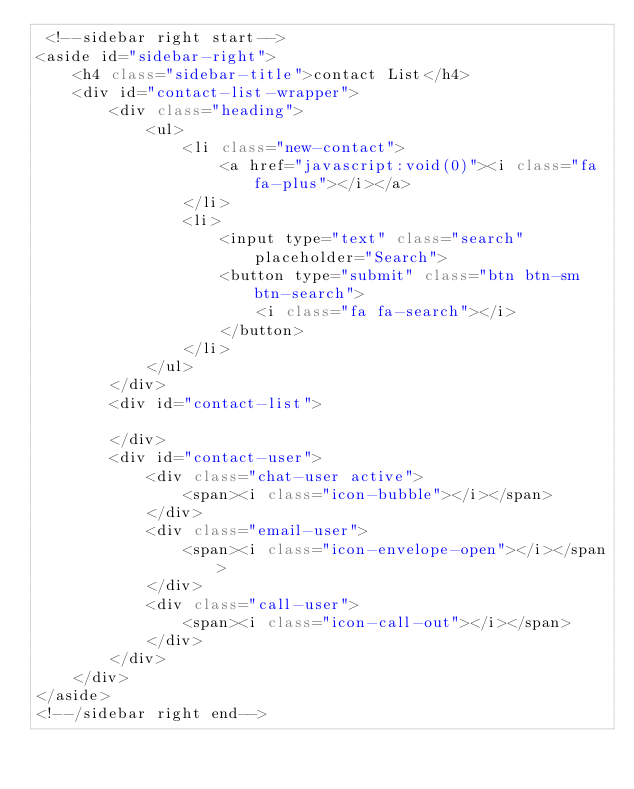<code> <loc_0><loc_0><loc_500><loc_500><_C#_> <!--sidebar right start-->
<aside id="sidebar-right">
    <h4 class="sidebar-title">contact List</h4>
    <div id="contact-list-wrapper">
        <div class="heading">
            <ul>
                <li class="new-contact">
                    <a href="javascript:void(0)"><i class="fa fa-plus"></i></a>
                </li>
                <li>
                    <input type="text" class="search" placeholder="Search">
                    <button type="submit" class="btn btn-sm btn-search">
                        <i class="fa fa-search"></i>
                    </button>
                </li>
            </ul>
        </div>
        <div id="contact-list">

        </div>
        <div id="contact-user">
            <div class="chat-user active">
                <span><i class="icon-bubble"></i></span>
            </div>
            <div class="email-user">
                <span><i class="icon-envelope-open"></i></span>
            </div>
            <div class="call-user">
                <span><i class="icon-call-out"></i></span>
            </div>
        </div>
    </div>
</aside>
<!--/sidebar right end--></code> 